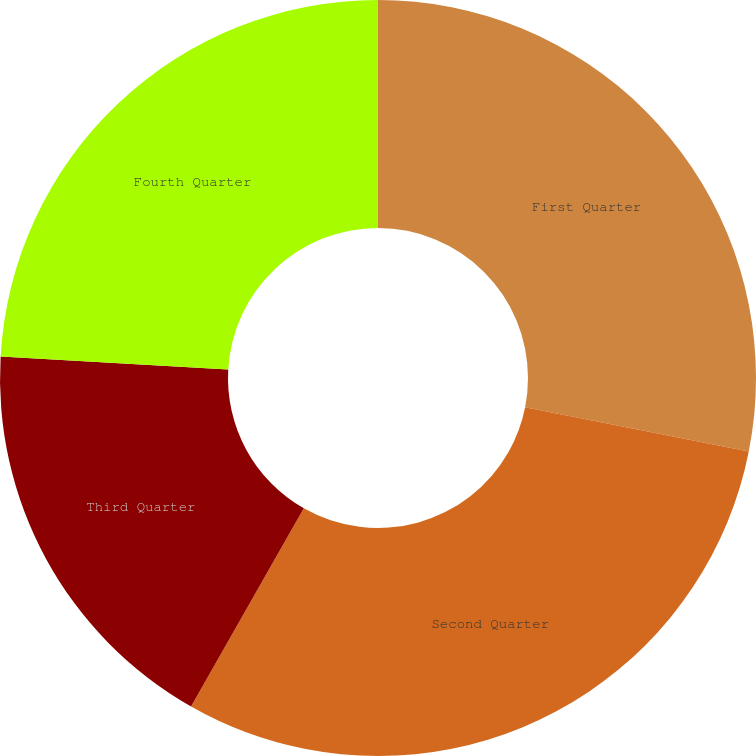Convert chart. <chart><loc_0><loc_0><loc_500><loc_500><pie_chart><fcel>First Quarter<fcel>Second Quarter<fcel>Third Quarter<fcel>Fourth Quarter<nl><fcel>28.12%<fcel>30.12%<fcel>17.67%<fcel>24.1%<nl></chart> 